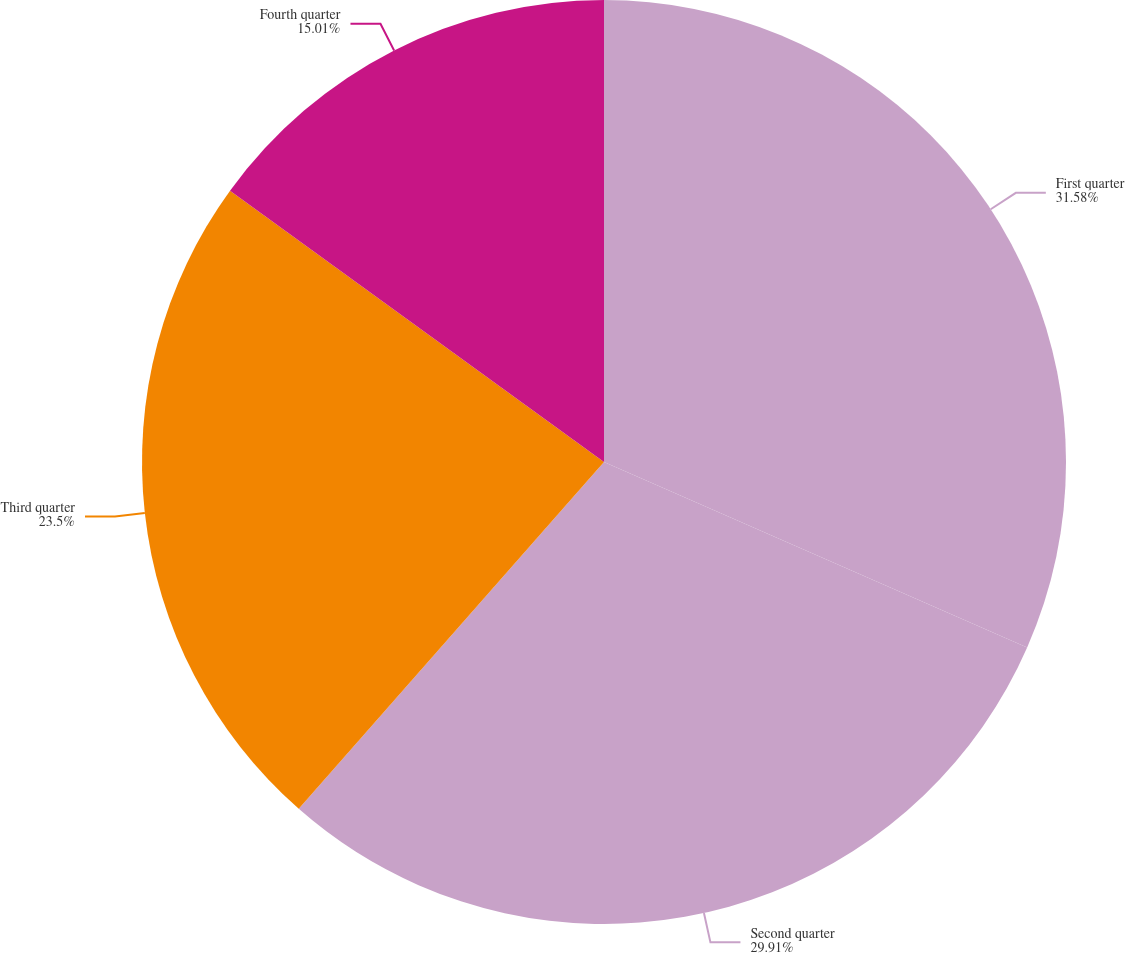Convert chart to OTSL. <chart><loc_0><loc_0><loc_500><loc_500><pie_chart><fcel>First quarter<fcel>Second quarter<fcel>Third quarter<fcel>Fourth quarter<nl><fcel>31.57%<fcel>29.91%<fcel>23.5%<fcel>15.01%<nl></chart> 